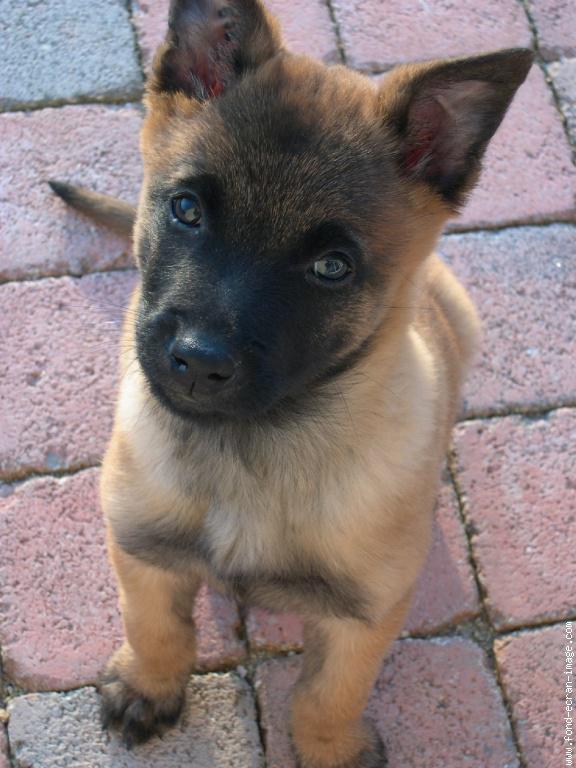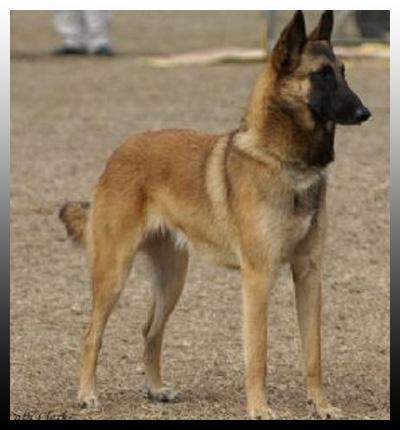The first image is the image on the left, the second image is the image on the right. For the images displayed, is the sentence "Some of the German Shepherds do not have their ears clipped." factually correct? Answer yes or no. No. The first image is the image on the left, the second image is the image on the right. For the images displayed, is the sentence "There are at least six dogs." factually correct? Answer yes or no. No. 